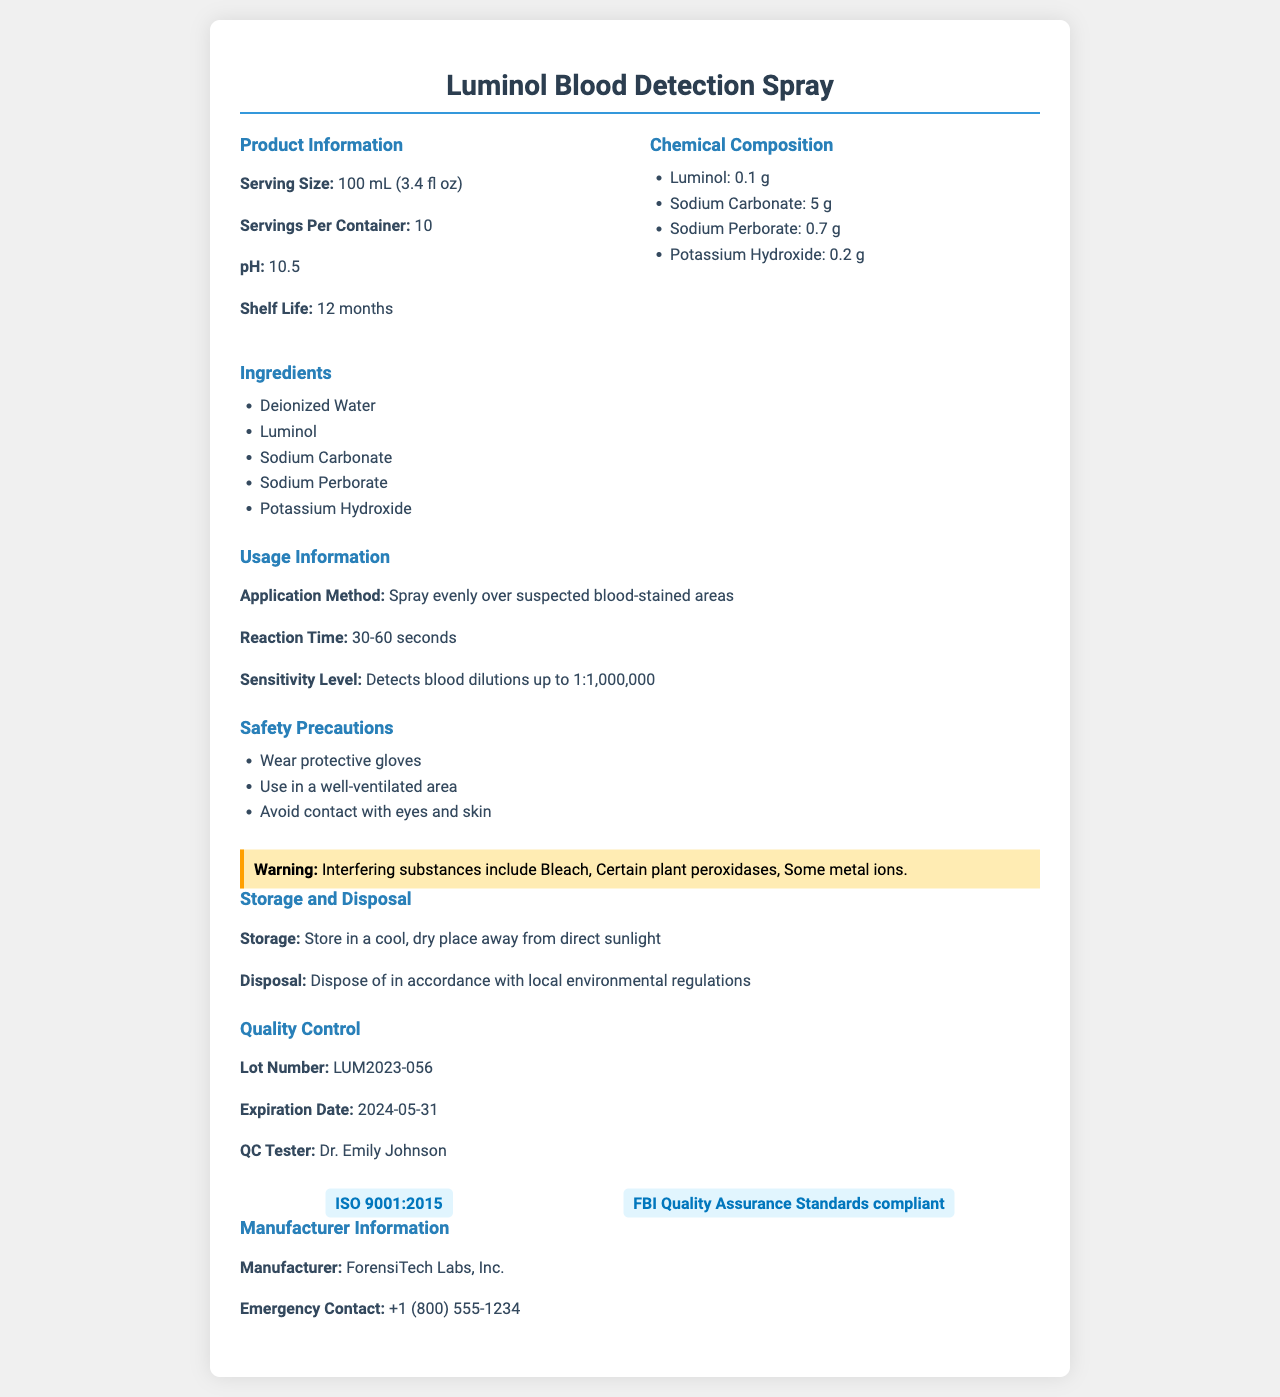which product is described in the document? The document starts with the product name: "Luminol Blood Detection Spray."
Answer: Luminol Blood Detection Spray what is the serving size of the product? Under the "Product Information" section, the serving size is listed as "100 mL (3.4 fl oz)."
Answer: 100 mL (3.4 fl oz) how many grams of sodium carbonate are in one serving? The "Chemical Composition" section lists the amount of Sodium Carbonate as "5 g."
Answer: 5 g what are the safety precautions for using this product? The "Safety Precautions" section outlines three precautions: "Wear protective gloves, use in a well-ventilated area, avoid contact with eyes and skin."
Answer: Wear protective gloves, use in a well-ventilated area, avoid contact with eyes and skin what's the shelf life of this product? The "Product Information" section lists the shelf life as "12 months."
Answer: 12 months which of the following is NOT an ingredient in this product? A. Deionized Water B. Luminol C. Potassium Hydroxide D. Acetone Acetone is not listed among the ingredients: "Deionized Water, Luminol, Sodium Carbonate, Sodium Perborate, Potassium Hydroxide."
Answer: D what is the pH of the Luminol Blood Detection Spray? The pH value is listed under the "Product Information" section as "pH: 10.5."
Answer: 10.5 who tested the quality control of this product? A. Dr. John Smith B. Dr. Emily Johnson C. Dr. James Brown D. Dr. Sarah Lee The "Quality Control" section lists the QC tester as "Dr. Emily Johnson."
Answer: B does the product detect blood dilutions up to 1:1,000,000? The "Usage Information" section states: "Detects blood dilutions up to 1:1,000,000."
Answer: Yes what is the sensitivity level for detecting blood using this product? The "Usage Information" section states the sensitivity level as: "Detects blood dilutions up to 1:1,000,000."
Answer: Detects blood dilutions up to 1:1,000,000 what should be avoided to prevent interference with the product's effectiveness? The document provides this list under the "Warning" section: "Interfering substances include Bleach, Certain plant peroxidases, Some metal ions."
Answer: Bleach, certain plant peroxidases, some metal ions what is the expiration date of the product? The "Quality Control" section lists the expiration date as "2024-05-31."
Answer: 2024-05-31 summarize the main information provided in the document. The document provides comprehensive details about the product, including how to use it, its chemical makeup, safety guidelines, interfering substances, storage and disposal protocols, quality control data, certifications, and manufacturer and emergency contact information.
Answer: The document outlines detailed product information for the Luminol Blood Detection Spray, including its serving size, chemical composition, pH, shelf life, ingredients, usage information, safety precautions, interfering substances, storage and disposal instructions, quality control, certifications, manufacturer information, and emergency contact details. how much luminol is there in one serving of the product? The "Chemical Composition" section lists the amount of Luminol as "0.1 g."
Answer: 0.1 g is the document sufficient to determine the cost of the product? The document provides detailed product information but does not mention the cost.
Answer: Not enough information 